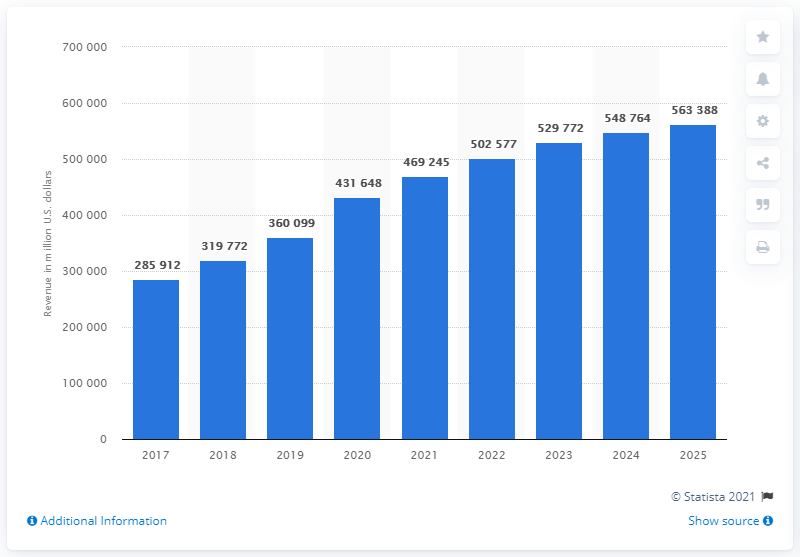What was the revenue from e-commerce in the United States in 2020? According to the bar graph depicted in the image, the revenue from e-commerce in the United States for the year 2020 reached approximately $431.65 billion, indicating a significant increase from the previous year. 